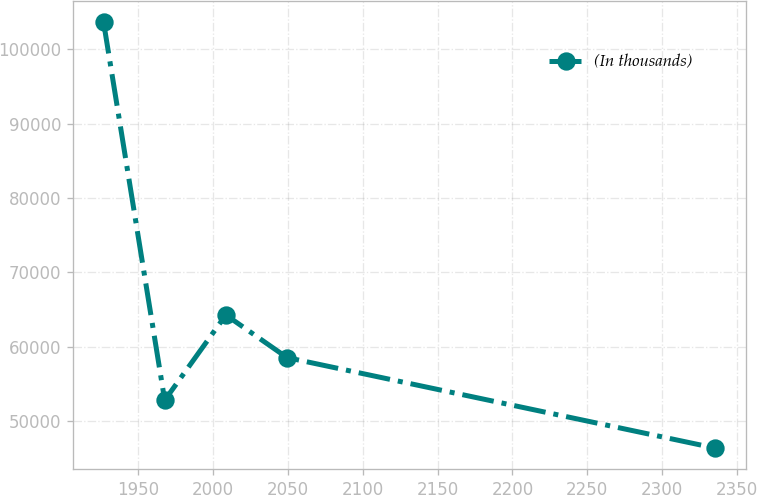<chart> <loc_0><loc_0><loc_500><loc_500><line_chart><ecel><fcel>(In thousands)<nl><fcel>1926.97<fcel>103717<nl><fcel>1967.82<fcel>52810.3<nl><fcel>2008.67<fcel>64279.8<nl><fcel>2049.52<fcel>58545<nl><fcel>2335.46<fcel>46369.5<nl></chart> 